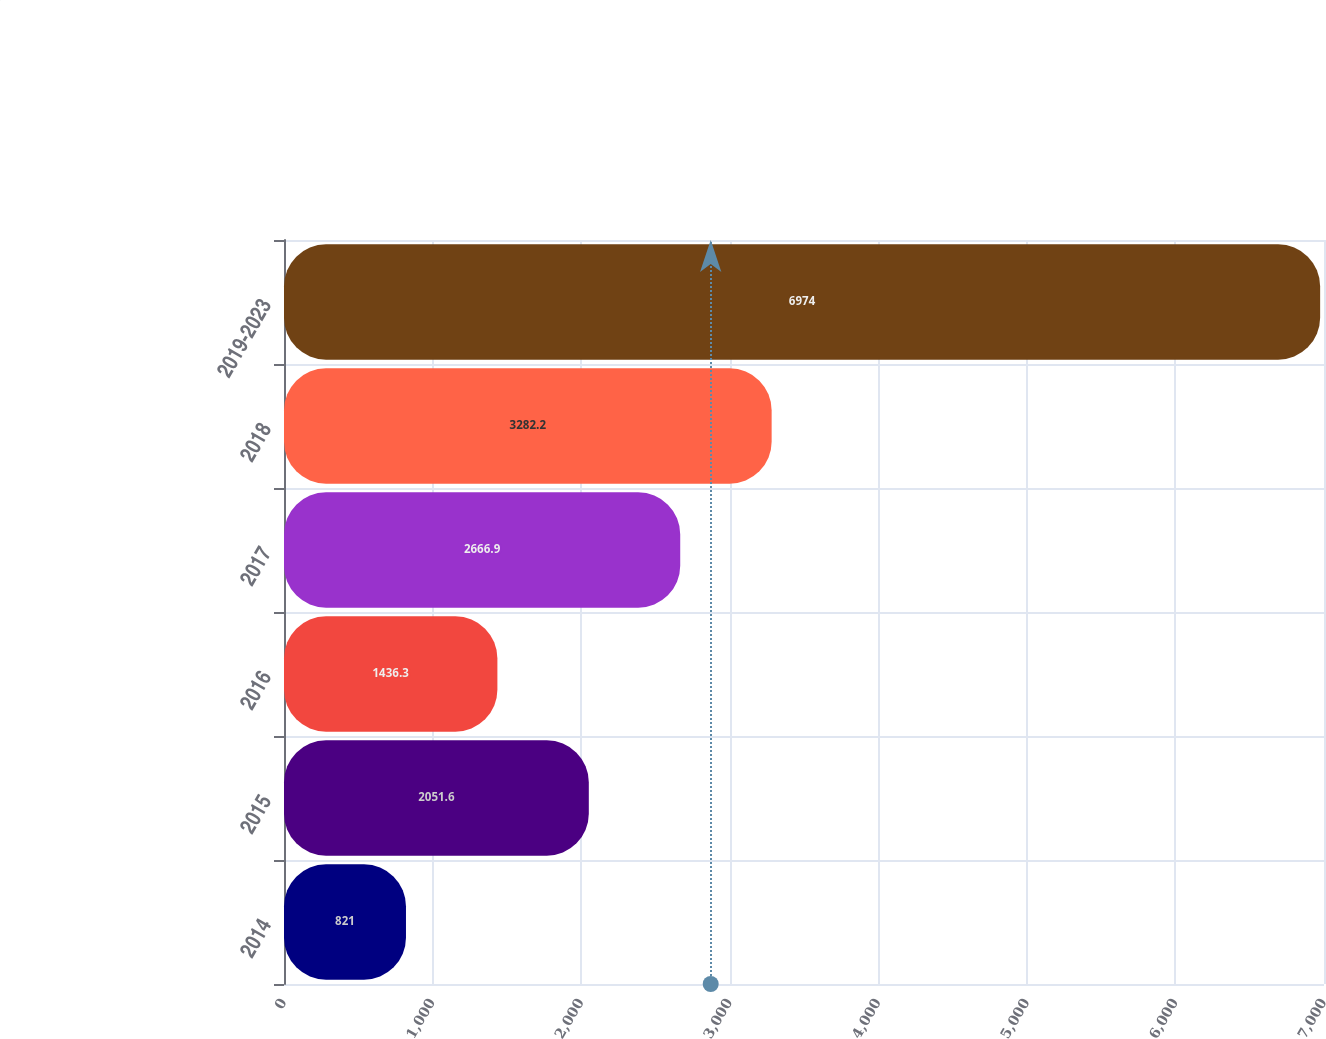Convert chart. <chart><loc_0><loc_0><loc_500><loc_500><bar_chart><fcel>2014<fcel>2015<fcel>2016<fcel>2017<fcel>2018<fcel>2019-2023<nl><fcel>821<fcel>2051.6<fcel>1436.3<fcel>2666.9<fcel>3282.2<fcel>6974<nl></chart> 